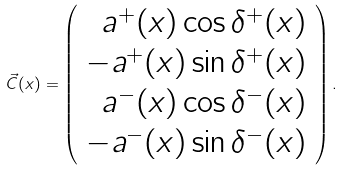<formula> <loc_0><loc_0><loc_500><loc_500>\vec { C } ( x ) = \left ( \begin{array} { r } a ^ { + } ( x ) \cos \delta ^ { + } ( x ) \\ - a ^ { + } ( x ) \sin \delta ^ { + } ( x ) \\ a ^ { - } ( x ) \cos \delta ^ { - } ( x ) \\ - a ^ { - } ( x ) \sin \delta ^ { - } ( x ) \end{array} \right ) .</formula> 